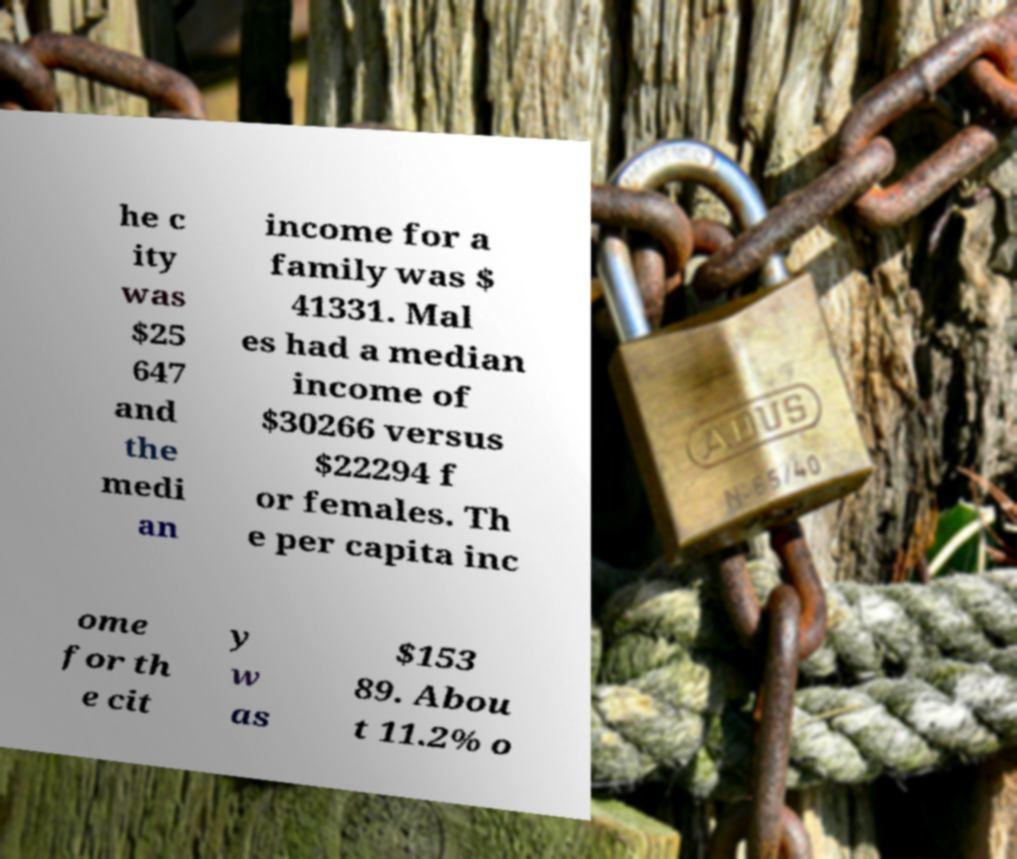Can you read and provide the text displayed in the image?This photo seems to have some interesting text. Can you extract and type it out for me? he c ity was $25 647 and the medi an income for a family was $ 41331. Mal es had a median income of $30266 versus $22294 f or females. Th e per capita inc ome for th e cit y w as $153 89. Abou t 11.2% o 